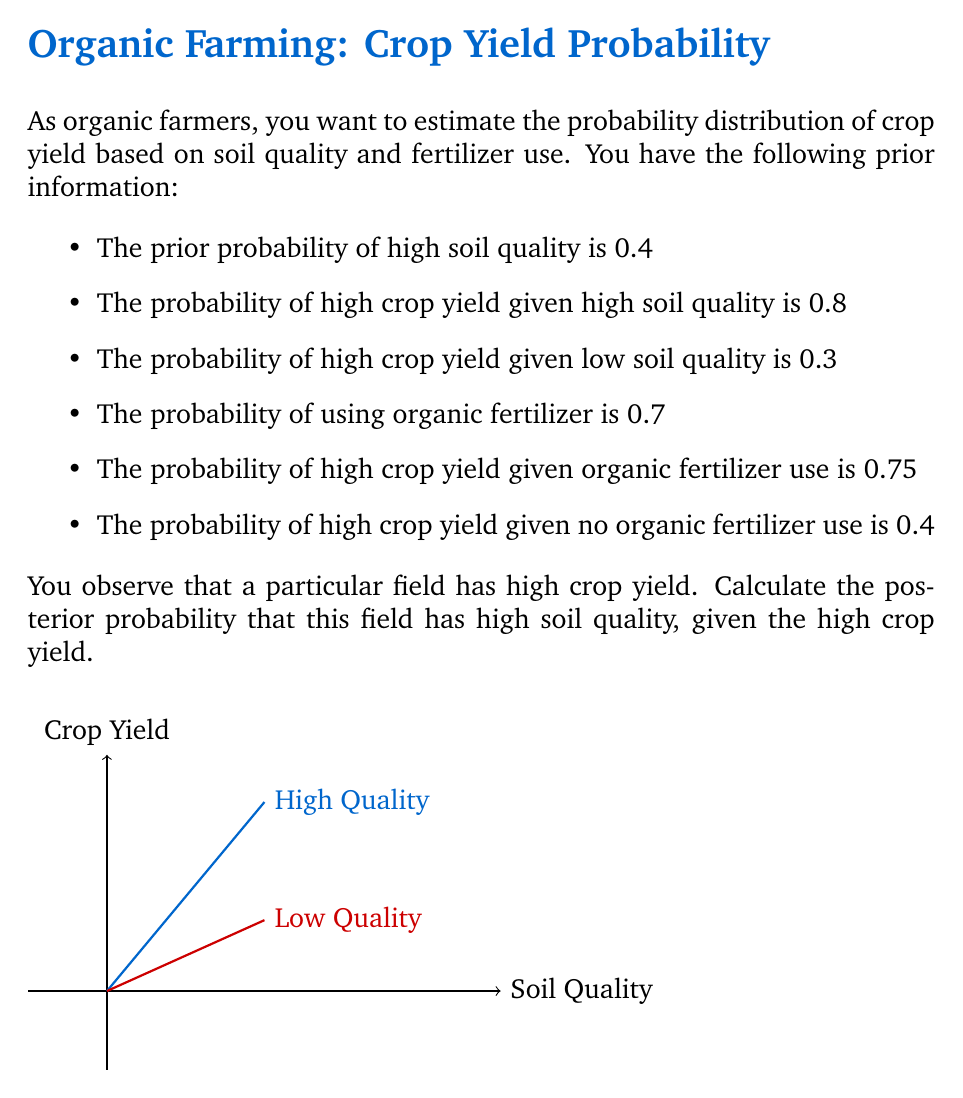Can you solve this math problem? To solve this problem, we'll use Bayes' theorem:

$$P(A|B) = \frac{P(B|A)P(A)}{P(B)}$$

Where:
A: High soil quality
B: High crop yield

Step 1: Calculate P(A), the prior probability of high soil quality
P(A) = 0.4

Step 2: Calculate P(B|A), the likelihood of high crop yield given high soil quality
P(B|A) = 0.8

Step 3: Calculate P(B), the marginal likelihood of high crop yield
We can use the law of total probability:
P(B) = P(B|A)P(A) + P(B|not A)P(not A)
     = 0.8 * 0.4 + 0.3 * 0.6
     = 0.32 + 0.18
     = 0.5

Step 4: Apply Bayes' theorem
$$P(A|B) = \frac{P(B|A)P(A)}{P(B)} = \frac{0.8 * 0.4}{0.5} = \frac{0.32}{0.5} = 0.64$$

Note: The information about organic fertilizer use is not directly relevant to this calculation, as we're only considering soil quality given crop yield. However, it could be used in a more complex model that incorporates both soil quality and fertilizer use.
Answer: 0.64 